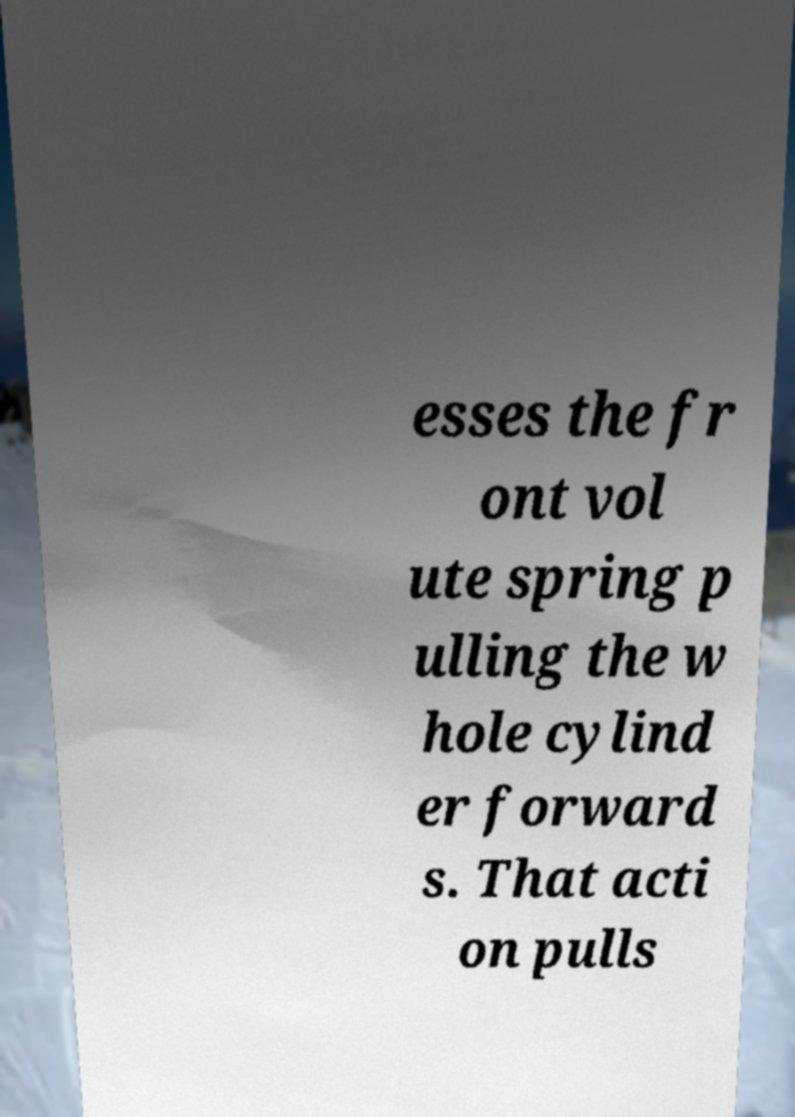Can you read and provide the text displayed in the image?This photo seems to have some interesting text. Can you extract and type it out for me? esses the fr ont vol ute spring p ulling the w hole cylind er forward s. That acti on pulls 